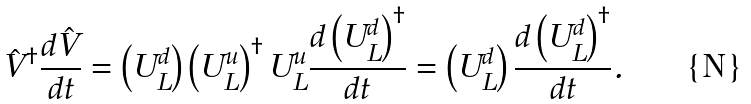<formula> <loc_0><loc_0><loc_500><loc_500>\hat { V } ^ { \dagger } \frac { d \hat { V } } { d t } = \left ( U _ { L } ^ { d } \right ) \left ( U _ { L } ^ { u } \right ) ^ { \dagger } U _ { L } ^ { u } \frac { d \left ( U _ { L } ^ { d } \right ) ^ { \dagger } } { d t } = \left ( U _ { L } ^ { d } \right ) \frac { d \left ( U _ { L } ^ { d } \right ) ^ { \dagger } } { d t } .</formula> 